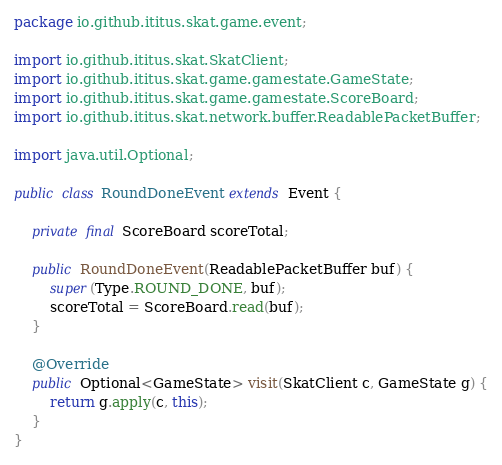Convert code to text. <code><loc_0><loc_0><loc_500><loc_500><_Java_>package io.github.ititus.skat.game.event;

import io.github.ititus.skat.SkatClient;
import io.github.ititus.skat.game.gamestate.GameState;
import io.github.ititus.skat.game.gamestate.ScoreBoard;
import io.github.ititus.skat.network.buffer.ReadablePacketBuffer;

import java.util.Optional;

public class RoundDoneEvent extends Event {

    private final ScoreBoard scoreTotal;

    public RoundDoneEvent(ReadablePacketBuffer buf) {
        super(Type.ROUND_DONE, buf);
        scoreTotal = ScoreBoard.read(buf);
    }

    @Override
    public Optional<GameState> visit(SkatClient c, GameState g) {
        return g.apply(c, this);
    }
}
</code> 